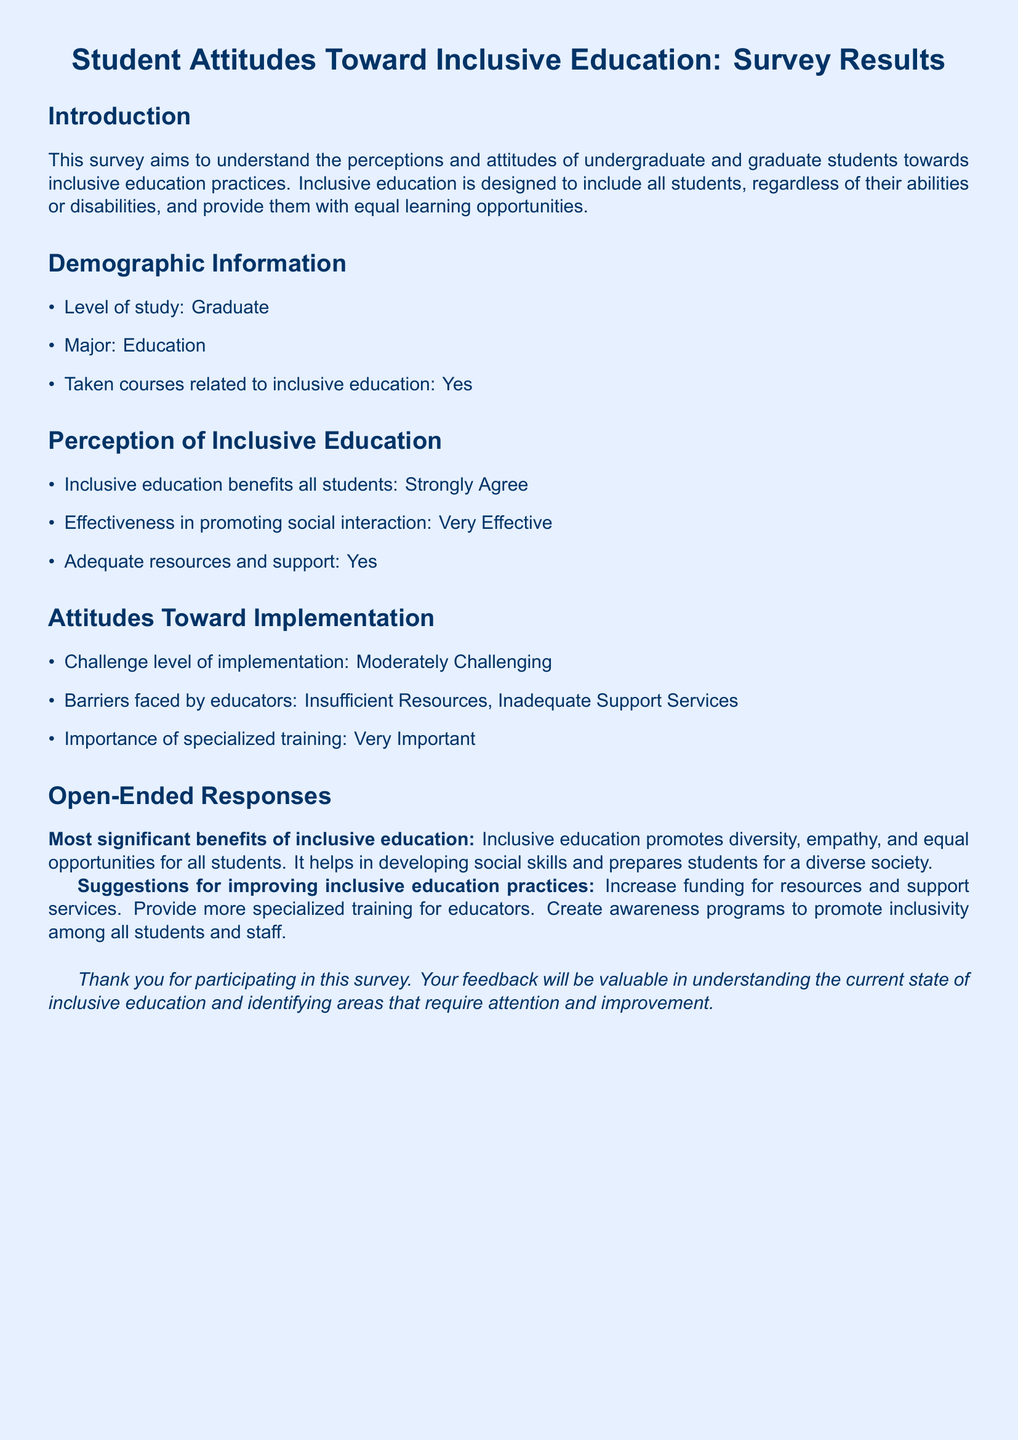what is the level of study of the respondent? The document states that the level of study is Graduate.
Answer: Graduate what is the respondent's major? The document specifies that the major is Education.
Answer: Education has the respondent taken courses related to inclusive education? The document indicates that the respondent has taken courses related to inclusive education.
Answer: Yes how does the respondent perceive the effectiveness of inclusive education in promoting social interaction? The respondent finds inclusive education to be Very Effective in promoting social interaction.
Answer: Very Effective what barriers to inclusive education implementation does the respondent identify? The document lists Insufficient Resources and Inadequate Support Services as barriers faced by educators.
Answer: Insufficient Resources, Inadequate Support Services what is the respondent's opinion on the importance of specialized training for educators in inclusive education? The document notes that the respondent considers specialized training to be Very Important.
Answer: Very Important what is one significant benefit of inclusive education mentioned by the respondent? The respondent highlights that inclusive education promotes diversity as one significant benefit.
Answer: Diversity what suggestion does the respondent provide for improving inclusive education practices? The document suggests increasing funding for resources and support services as a way to improve inclusive education practices.
Answer: Increase funding for resources and support services 